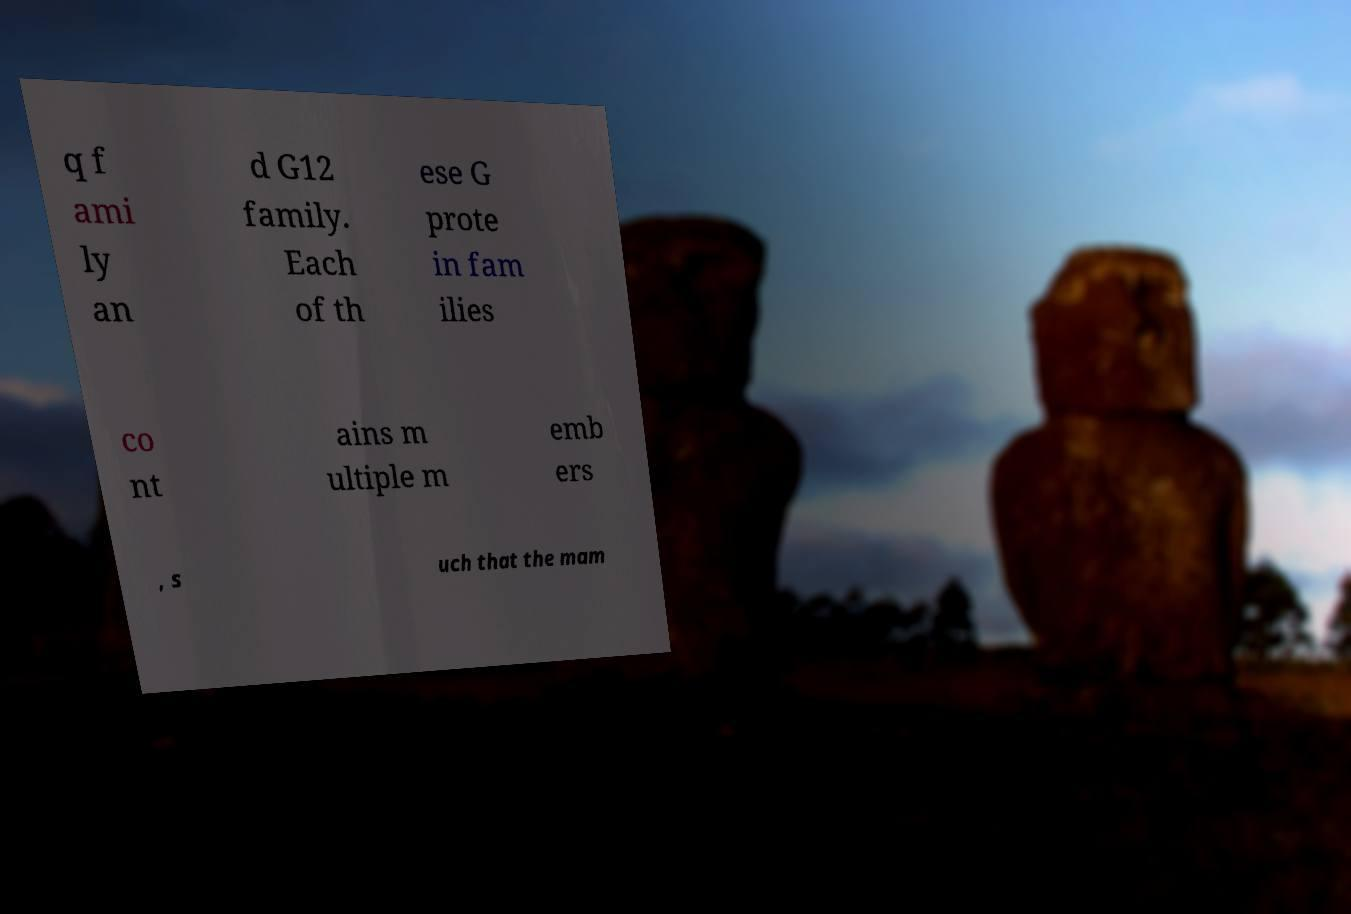Please identify and transcribe the text found in this image. q f ami ly an d G12 family. Each of th ese G prote in fam ilies co nt ains m ultiple m emb ers , s uch that the mam 